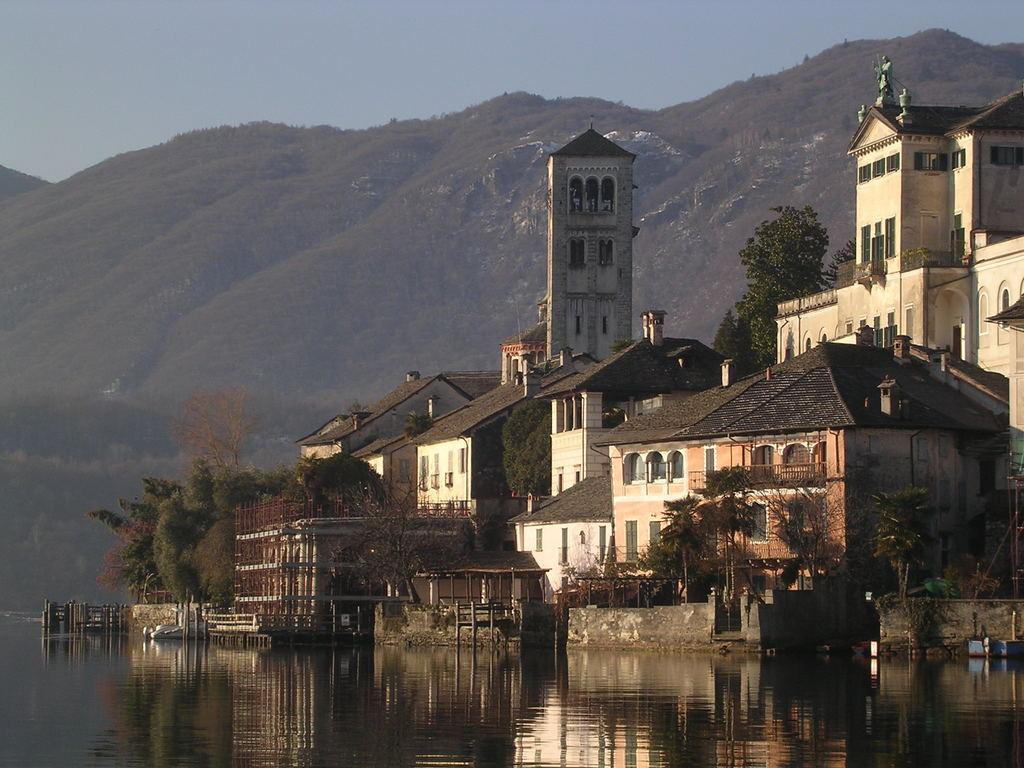What is the primary element visible in the image? There is water in the image. What structures can be seen in the image? There are buildings in the image. What type of vegetation is present in the image? There are trees in the image. What can be seen in the distance in the image? In the background, there are hills visible. What is visible above the scene in the image? The sky is visible in the background. What type of account is being managed by the rod in the image? There is no rod or account present in the image. How does the care for the trees in the image differ from the care for the buildings? The image does not provide information about the care for the trees or buildings, so we cannot compare them. 